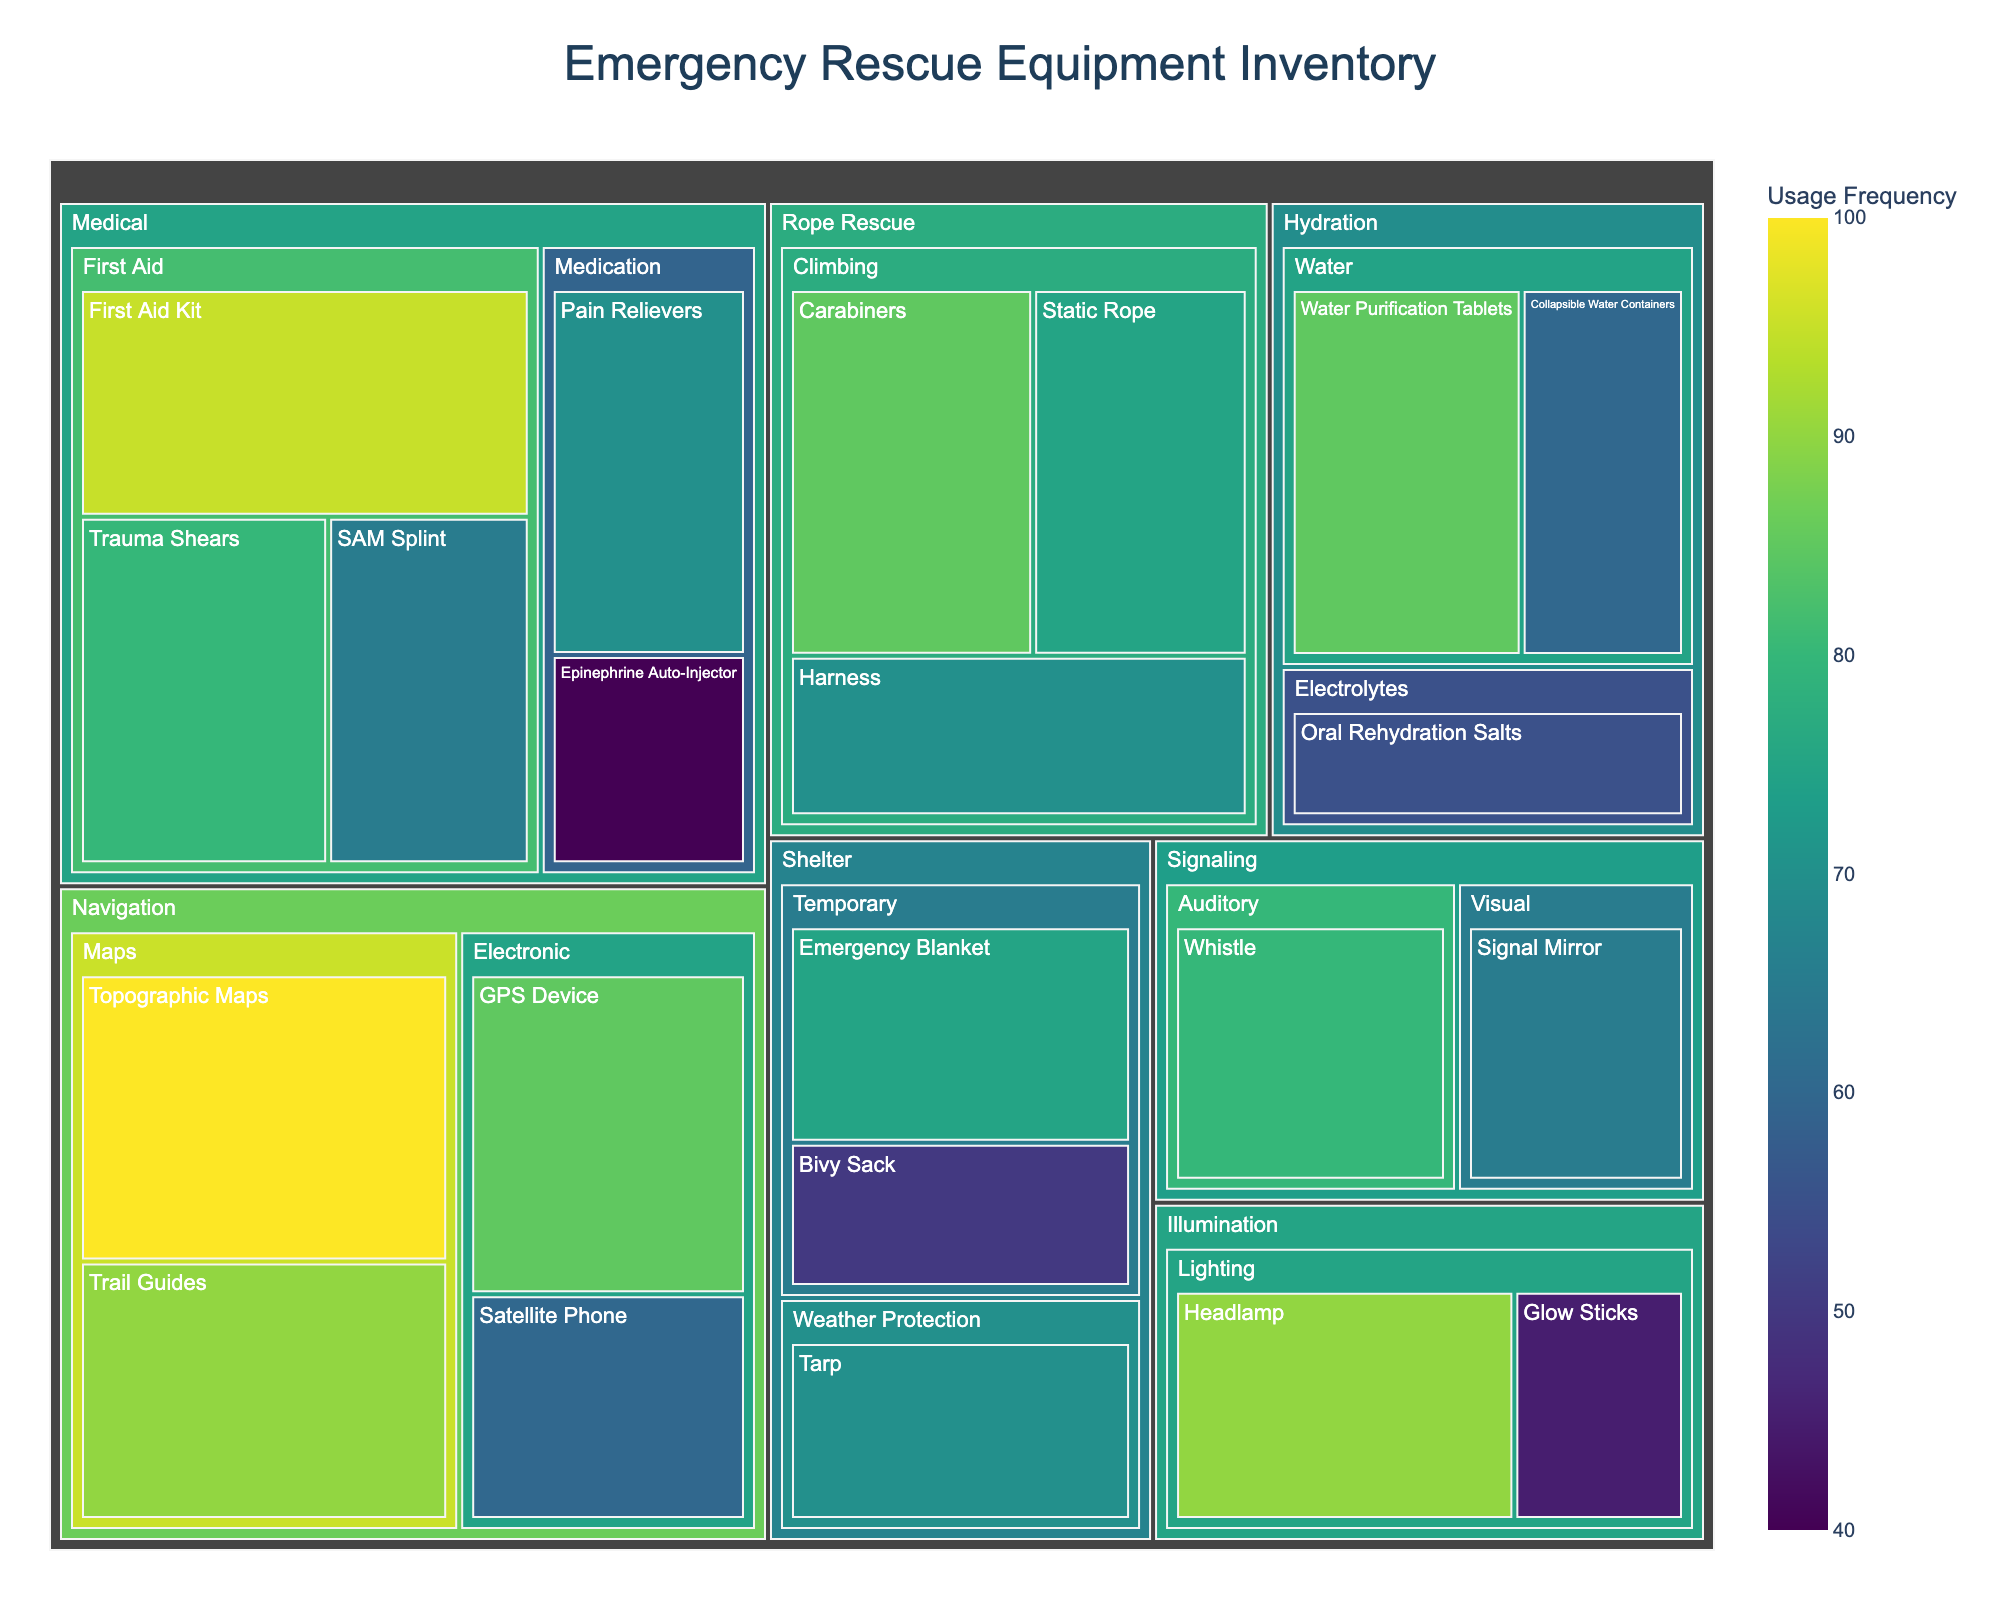What is the title of the figure? The title is usually displayed prominently at the top and is meant to provide a brief description of the treemap. In this case, the title "Emergency Rescue Equipment Inventory" can be found at the top.
Answer: Emergency Rescue Equipment Inventory Which item has the highest usage frequency? The treemap uses size and color to represent the frequency. The item with the largest area and darkest shade in the highest category would be the one with the highest frequency. The "Topographic Maps" in the Navigation category are the darkest and largest, indicating the highest frequency.
Answer: Topographic Maps How many items are there in the Medical category? Each tile in the Medical category represents an individual item. By counting these tiles, we see there are six items: First Aid Kit, Trauma Shears, SAM Splint, Epinephrine Auto-Injector, Pain Relievers.
Answer: 5 What's the combined frequency of all the navigational tools? To determine this, we need to sum up the frequency values for all items under the Navigation category: (Topographic Maps: 100) + (Trail Guides: 90) + (GPS Device: 85) + (Satellite Phone: 60). Adding up these values gives us 335.
Answer: 335 Which subcategory has more items: Temporary Shelter or Weather Protection Shelter? Each subcategory is represented by a collection of items. We count the items in both subcategories of the Shelter category. Temporary has two items (Emergency Blanket and Bivy Sack) while Weather Protection has one (Tarp).
Answer: Temporary Shelter What is the difference in frequency between the most and least used items in the Illumination category? In the Illumination category: Headlamp has a frequency of 90 and Glow Sticks have a frequency of 45. The difference is 90 - 45.
Answer: 45 Which two categories have items with the same highest frequency? By examining each category for the item with the highest frequency: Medical (First Aid Kit: 95), Navigation (Topographic Maps: 100), Shelter (Tarp: 70), Hydration (Water Purification Tablets: 85), Illumination (Headlamp: 90), Signaling (Whistle: 80), Rope Rescue (Carabiners: 85). Both Navigation and Medical have items with the highest frequency.
Answer: Medical and Navigation What's the average frequency of items in the Hydration category? To find the average frequency, sum up the frequencies of all items in the Hydration category (Water Purification Tablets: 85, Collapsible Water Containers: 60, Oral Rehydration Salts: 55) then divide by the number of items: (85 + 60 + 55) / 3 = 200 / 3.
Answer: 66.67 Which has a higher average frequency: Electronic or Maps subcategory in Navigation? Calculate the average frequency for both subcategories by summing their item frequencies and dividing by the number of items. For Maps: (Topographic Maps: 100 + Trail Guides: 90) / 2 = 190 / 2 = 95. For Electronic: (GPS Device: 85 + Satellite Phone: 60) / 2 = 145 / 2 = 72.5. Maps have a higher average frequency.
Answer: Maps What's the least frequently used item in the Medical category? The item with the smallest area and lightest shade within the Medical category is the least frequently used. The "Epinephrine Auto-Injector" at a frequency of 40 is the lightest and smallest.
Answer: Epinephrine Auto-Injector 